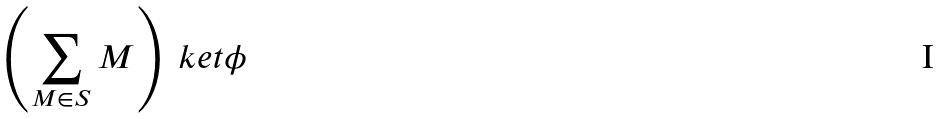Convert formula to latex. <formula><loc_0><loc_0><loc_500><loc_500>\left ( \sum _ { M \in S } M \right ) \ k e t { \phi }</formula> 